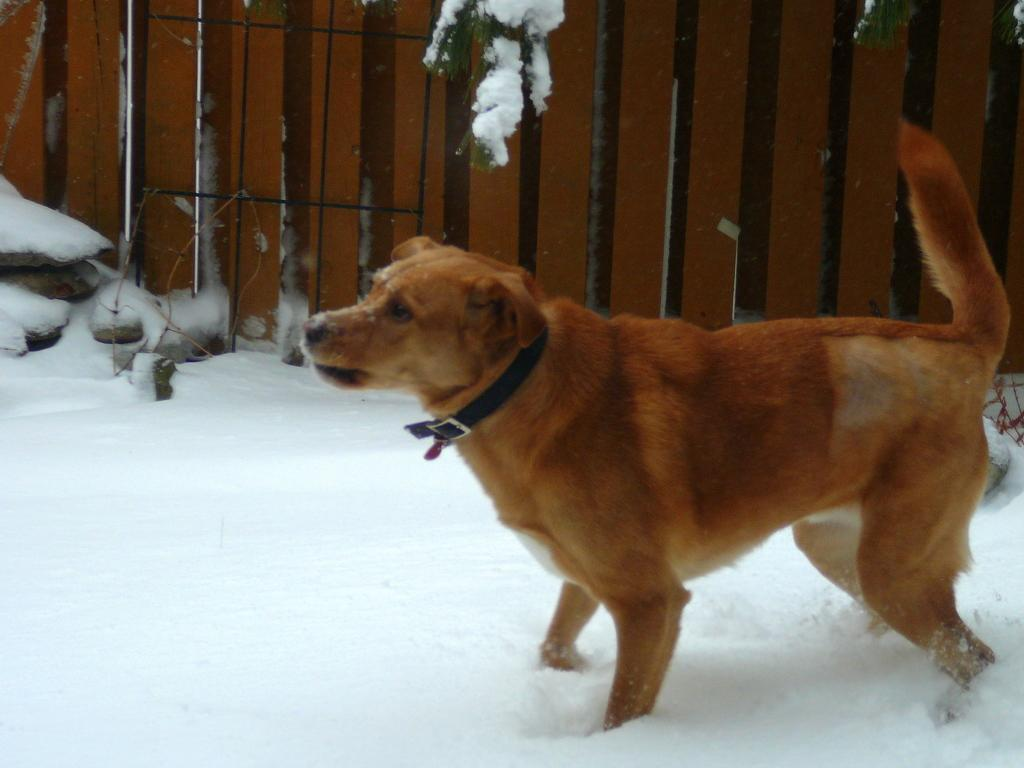What animal can be seen in the image? There is a dog in the image. What surface is the dog standing on? The dog is standing on the snow. What type of architectural feature is visible in the background of the image? There are iron grills in the background of the image. What type of weather condition is depicted in the image? There is snow visible in the background of the image. How many beds can be seen in the image? There are no beds present in the image. Can you describe the hammer that the dog is holding in the image? There is no hammer present in the image; the dog is simply standing on the snow. 